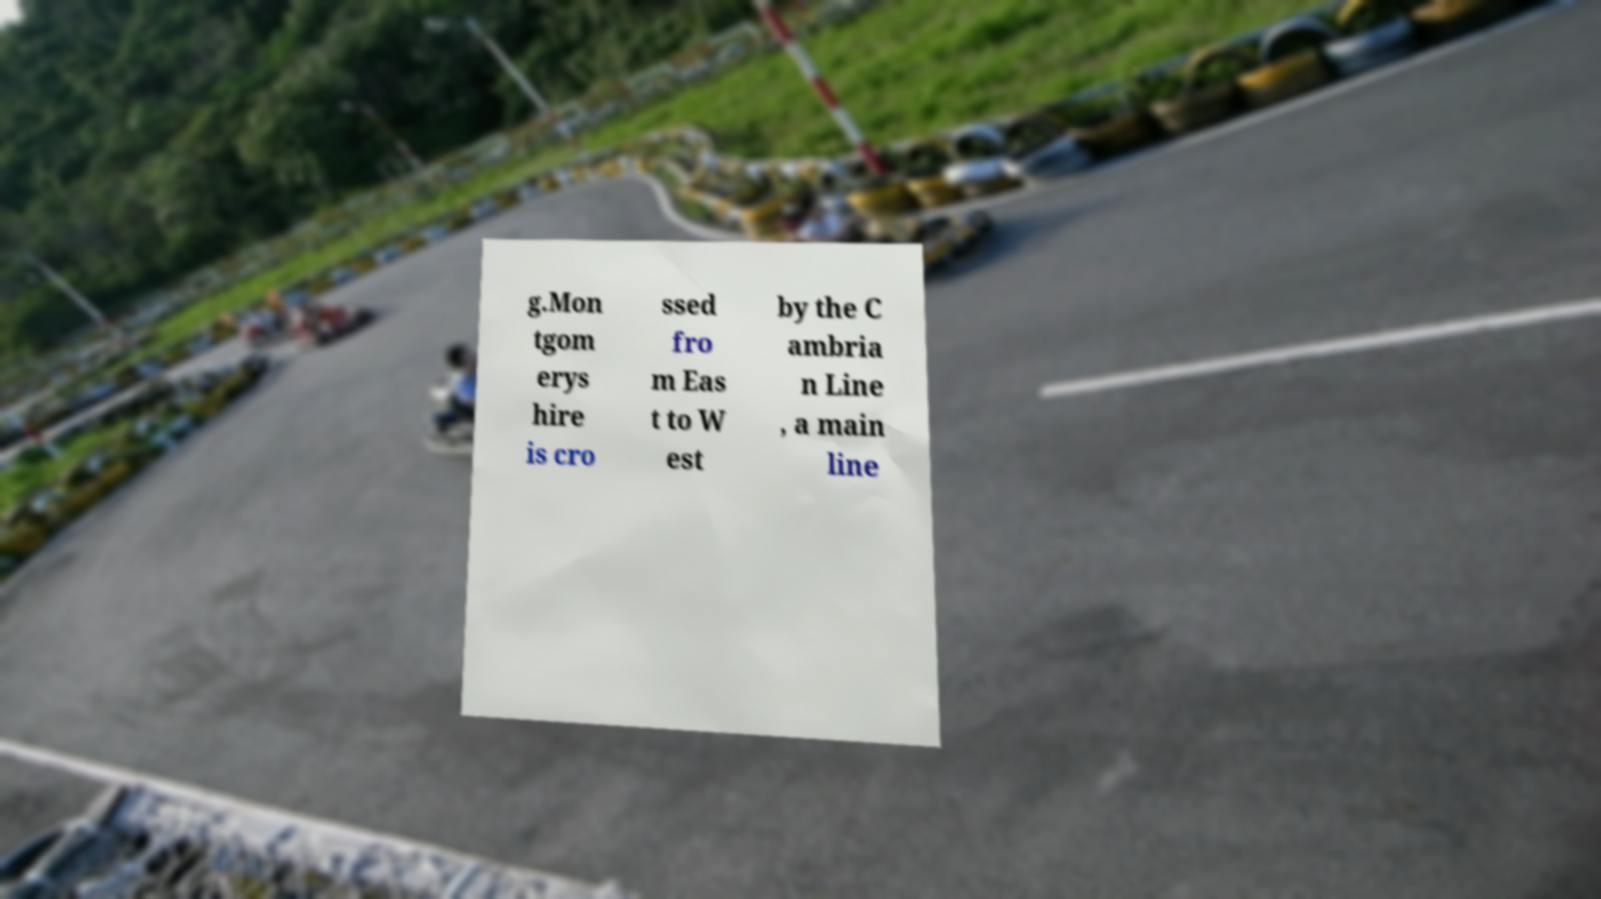Could you assist in decoding the text presented in this image and type it out clearly? g.Mon tgom erys hire is cro ssed fro m Eas t to W est by the C ambria n Line , a main line 